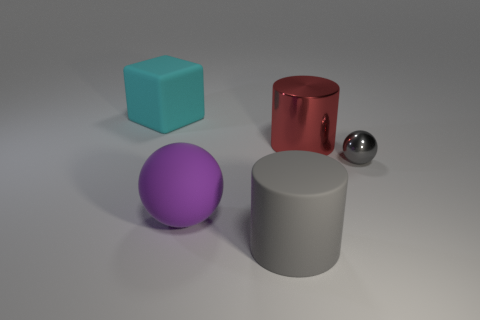What can you infer about the surface on which the objects are placed? The surface appears to be flat and evenly colored with a muted tone that does not reflect light as strongly as the objects resting on it. This suggests it might be a matte material, providing a neutral background that emphasizes the objects. How do the different materials of the objects contribute to the overall aesthetic of this scene? The interplay of materials in this scene creates a visually engaging contrast. The matte surface grounds the composition, while the shiny, reflective qualities of the metallic objects draw the eye and create highlights. The colored objects add vibrancy and provide a sense of balance with their diverse textures and finishes. 